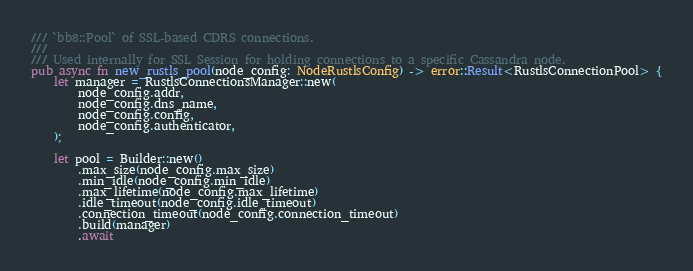Convert code to text. <code><loc_0><loc_0><loc_500><loc_500><_Rust_>/// `bb8::Pool` of SSL-based CDRS connections.
///
/// Used internally for SSL Session for holding connections to a specific Cassandra node.
pub async fn new_rustls_pool(node_config: NodeRustlsConfig) -> error::Result<RustlsConnectionPool> {
    let manager = RustlsConnectionsManager::new(
        node_config.addr,
        node_config.dns_name,
        node_config.config,
        node_config.authenticator,
    );

    let pool = Builder::new()
        .max_size(node_config.max_size)
        .min_idle(node_config.min_idle)
        .max_lifetime(node_config.max_lifetime)
        .idle_timeout(node_config.idle_timeout)
        .connection_timeout(node_config.connection_timeout)
        .build(manager)
        .await</code> 